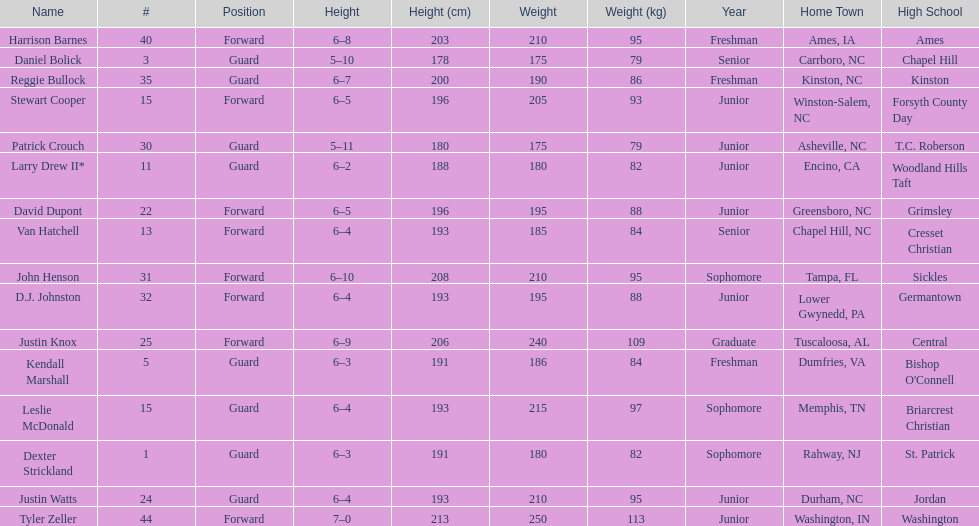How many players were taller than van hatchell? 7. 